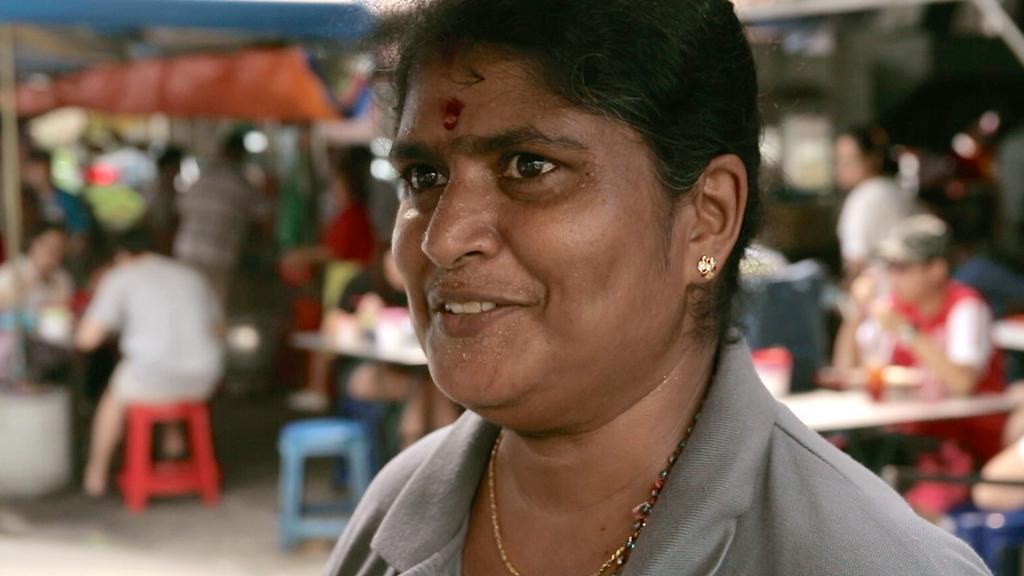Could you give a brief overview of what you see in this image? In this picture we can see a woman is smiling in the front, in the background there are some people standing and some people are sitting, we can also see tables and chairs, there is a blur background. 